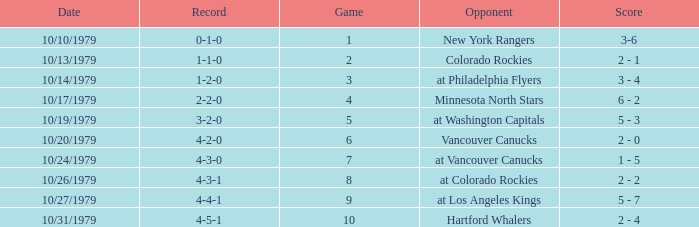What date is the record 4-3-0? 10/24/1979. 